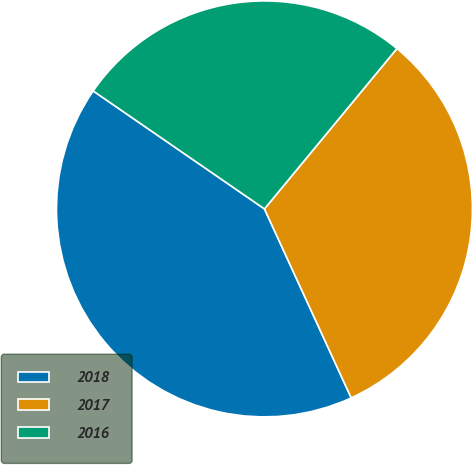<chart> <loc_0><loc_0><loc_500><loc_500><pie_chart><fcel>2018<fcel>2017<fcel>2016<nl><fcel>41.45%<fcel>32.16%<fcel>26.39%<nl></chart> 